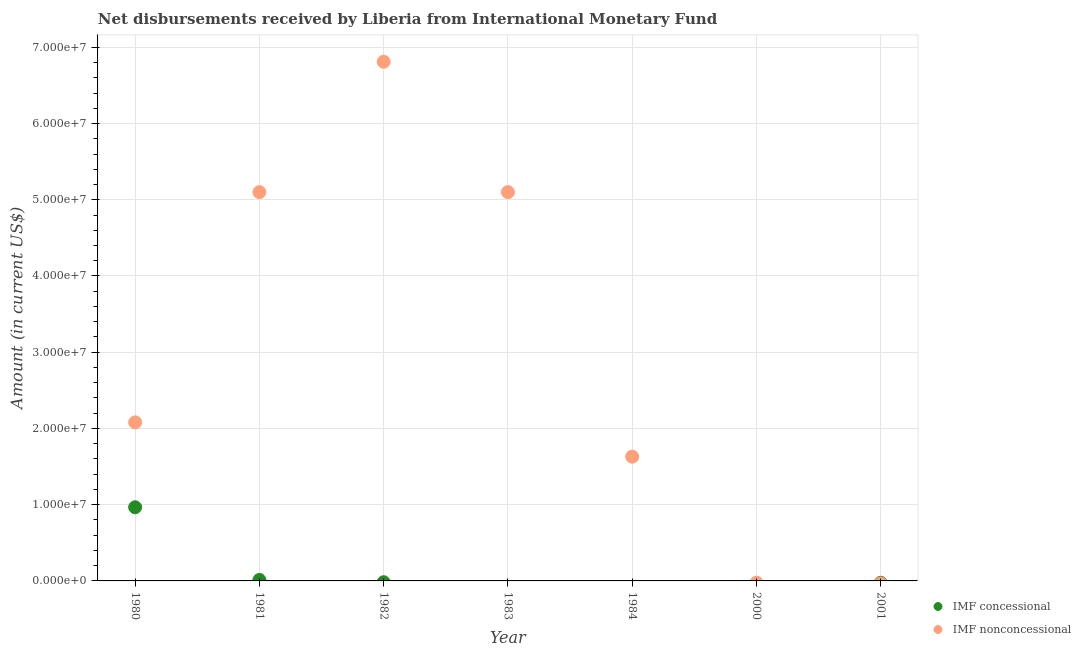Is the number of dotlines equal to the number of legend labels?
Provide a short and direct response. No. What is the net concessional disbursements from imf in 2001?
Offer a very short reply. 0. Across all years, what is the maximum net concessional disbursements from imf?
Your answer should be very brief. 9.66e+06. Across all years, what is the minimum net concessional disbursements from imf?
Your response must be concise. 0. What is the total net concessional disbursements from imf in the graph?
Offer a terse response. 9.79e+06. What is the difference between the net non concessional disbursements from imf in 1982 and that in 1983?
Ensure brevity in your answer.  1.71e+07. What is the average net concessional disbursements from imf per year?
Provide a short and direct response. 1.40e+06. In the year 1981, what is the difference between the net concessional disbursements from imf and net non concessional disbursements from imf?
Offer a very short reply. -5.09e+07. In how many years, is the net concessional disbursements from imf greater than 42000000 US$?
Ensure brevity in your answer.  0. Is the net non concessional disbursements from imf in 1983 less than that in 1984?
Offer a very short reply. No. What is the difference between the highest and the second highest net non concessional disbursements from imf?
Your answer should be very brief. 1.71e+07. What is the difference between the highest and the lowest net non concessional disbursements from imf?
Ensure brevity in your answer.  6.81e+07. Does the net concessional disbursements from imf monotonically increase over the years?
Your response must be concise. No. Is the net non concessional disbursements from imf strictly greater than the net concessional disbursements from imf over the years?
Provide a short and direct response. No. Is the net concessional disbursements from imf strictly less than the net non concessional disbursements from imf over the years?
Your answer should be very brief. No. Are the values on the major ticks of Y-axis written in scientific E-notation?
Ensure brevity in your answer.  Yes. Does the graph contain grids?
Offer a terse response. Yes. How many legend labels are there?
Make the answer very short. 2. What is the title of the graph?
Ensure brevity in your answer.  Net disbursements received by Liberia from International Monetary Fund. Does "Goods and services" appear as one of the legend labels in the graph?
Make the answer very short. No. What is the Amount (in current US$) of IMF concessional in 1980?
Your answer should be compact. 9.66e+06. What is the Amount (in current US$) of IMF nonconcessional in 1980?
Give a very brief answer. 2.08e+07. What is the Amount (in current US$) of IMF concessional in 1981?
Offer a terse response. 1.29e+05. What is the Amount (in current US$) in IMF nonconcessional in 1981?
Offer a terse response. 5.10e+07. What is the Amount (in current US$) of IMF nonconcessional in 1982?
Offer a very short reply. 6.81e+07. What is the Amount (in current US$) of IMF concessional in 1983?
Make the answer very short. 0. What is the Amount (in current US$) of IMF nonconcessional in 1983?
Offer a terse response. 5.10e+07. What is the Amount (in current US$) of IMF nonconcessional in 1984?
Make the answer very short. 1.63e+07. What is the Amount (in current US$) in IMF concessional in 2000?
Keep it short and to the point. 0. What is the Amount (in current US$) in IMF nonconcessional in 2001?
Offer a terse response. 0. Across all years, what is the maximum Amount (in current US$) in IMF concessional?
Offer a terse response. 9.66e+06. Across all years, what is the maximum Amount (in current US$) in IMF nonconcessional?
Give a very brief answer. 6.81e+07. Across all years, what is the minimum Amount (in current US$) in IMF concessional?
Provide a short and direct response. 0. Across all years, what is the minimum Amount (in current US$) in IMF nonconcessional?
Your answer should be very brief. 0. What is the total Amount (in current US$) of IMF concessional in the graph?
Keep it short and to the point. 9.79e+06. What is the total Amount (in current US$) in IMF nonconcessional in the graph?
Your response must be concise. 2.07e+08. What is the difference between the Amount (in current US$) of IMF concessional in 1980 and that in 1981?
Your answer should be very brief. 9.53e+06. What is the difference between the Amount (in current US$) in IMF nonconcessional in 1980 and that in 1981?
Offer a very short reply. -3.02e+07. What is the difference between the Amount (in current US$) in IMF nonconcessional in 1980 and that in 1982?
Ensure brevity in your answer.  -4.73e+07. What is the difference between the Amount (in current US$) of IMF nonconcessional in 1980 and that in 1983?
Offer a very short reply. -3.02e+07. What is the difference between the Amount (in current US$) in IMF nonconcessional in 1980 and that in 1984?
Give a very brief answer. 4.50e+06. What is the difference between the Amount (in current US$) in IMF nonconcessional in 1981 and that in 1982?
Offer a very short reply. -1.71e+07. What is the difference between the Amount (in current US$) in IMF nonconcessional in 1981 and that in 1984?
Ensure brevity in your answer.  3.47e+07. What is the difference between the Amount (in current US$) in IMF nonconcessional in 1982 and that in 1983?
Your answer should be compact. 1.71e+07. What is the difference between the Amount (in current US$) in IMF nonconcessional in 1982 and that in 1984?
Offer a very short reply. 5.18e+07. What is the difference between the Amount (in current US$) of IMF nonconcessional in 1983 and that in 1984?
Offer a terse response. 3.47e+07. What is the difference between the Amount (in current US$) of IMF concessional in 1980 and the Amount (in current US$) of IMF nonconcessional in 1981?
Your answer should be very brief. -4.13e+07. What is the difference between the Amount (in current US$) of IMF concessional in 1980 and the Amount (in current US$) of IMF nonconcessional in 1982?
Keep it short and to the point. -5.84e+07. What is the difference between the Amount (in current US$) of IMF concessional in 1980 and the Amount (in current US$) of IMF nonconcessional in 1983?
Provide a short and direct response. -4.13e+07. What is the difference between the Amount (in current US$) of IMF concessional in 1980 and the Amount (in current US$) of IMF nonconcessional in 1984?
Provide a succinct answer. -6.64e+06. What is the difference between the Amount (in current US$) of IMF concessional in 1981 and the Amount (in current US$) of IMF nonconcessional in 1982?
Provide a short and direct response. -6.80e+07. What is the difference between the Amount (in current US$) of IMF concessional in 1981 and the Amount (in current US$) of IMF nonconcessional in 1983?
Make the answer very short. -5.09e+07. What is the difference between the Amount (in current US$) of IMF concessional in 1981 and the Amount (in current US$) of IMF nonconcessional in 1984?
Ensure brevity in your answer.  -1.62e+07. What is the average Amount (in current US$) in IMF concessional per year?
Keep it short and to the point. 1.40e+06. What is the average Amount (in current US$) of IMF nonconcessional per year?
Ensure brevity in your answer.  2.96e+07. In the year 1980, what is the difference between the Amount (in current US$) in IMF concessional and Amount (in current US$) in IMF nonconcessional?
Ensure brevity in your answer.  -1.11e+07. In the year 1981, what is the difference between the Amount (in current US$) of IMF concessional and Amount (in current US$) of IMF nonconcessional?
Make the answer very short. -5.09e+07. What is the ratio of the Amount (in current US$) of IMF concessional in 1980 to that in 1981?
Give a very brief answer. 74.91. What is the ratio of the Amount (in current US$) of IMF nonconcessional in 1980 to that in 1981?
Keep it short and to the point. 0.41. What is the ratio of the Amount (in current US$) in IMF nonconcessional in 1980 to that in 1982?
Your answer should be very brief. 0.31. What is the ratio of the Amount (in current US$) in IMF nonconcessional in 1980 to that in 1983?
Your response must be concise. 0.41. What is the ratio of the Amount (in current US$) in IMF nonconcessional in 1980 to that in 1984?
Your answer should be very brief. 1.28. What is the ratio of the Amount (in current US$) in IMF nonconcessional in 1981 to that in 1982?
Make the answer very short. 0.75. What is the ratio of the Amount (in current US$) in IMF nonconcessional in 1981 to that in 1983?
Keep it short and to the point. 1. What is the ratio of the Amount (in current US$) in IMF nonconcessional in 1981 to that in 1984?
Your answer should be compact. 3.13. What is the ratio of the Amount (in current US$) in IMF nonconcessional in 1982 to that in 1983?
Provide a short and direct response. 1.34. What is the ratio of the Amount (in current US$) of IMF nonconcessional in 1982 to that in 1984?
Give a very brief answer. 4.18. What is the ratio of the Amount (in current US$) of IMF nonconcessional in 1983 to that in 1984?
Keep it short and to the point. 3.13. What is the difference between the highest and the second highest Amount (in current US$) in IMF nonconcessional?
Provide a short and direct response. 1.71e+07. What is the difference between the highest and the lowest Amount (in current US$) in IMF concessional?
Ensure brevity in your answer.  9.66e+06. What is the difference between the highest and the lowest Amount (in current US$) of IMF nonconcessional?
Offer a very short reply. 6.81e+07. 